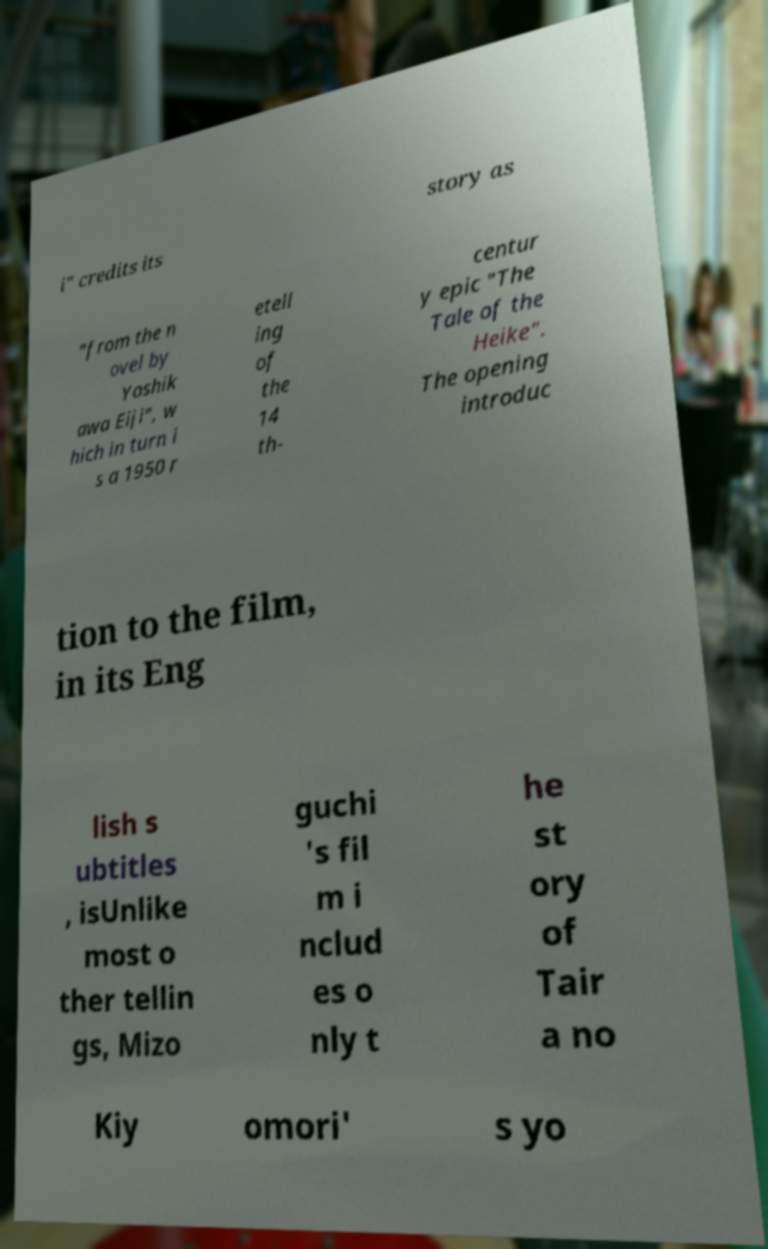Can you read and provide the text displayed in the image?This photo seems to have some interesting text. Can you extract and type it out for me? i" credits its story as "from the n ovel by Yoshik awa Eiji", w hich in turn i s a 1950 r etell ing of the 14 th- centur y epic "The Tale of the Heike". The opening introduc tion to the film, in its Eng lish s ubtitles , isUnlike most o ther tellin gs, Mizo guchi 's fil m i nclud es o nly t he st ory of Tair a no Kiy omori' s yo 